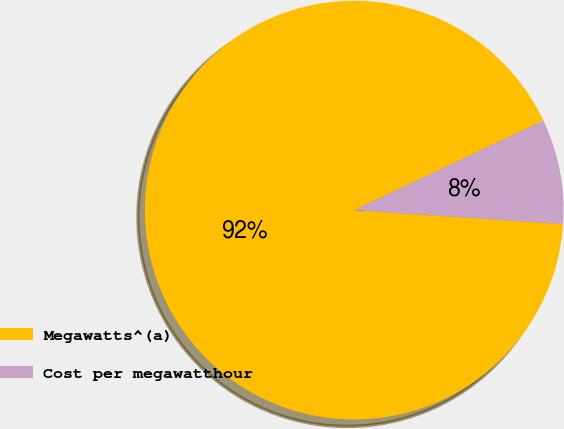Convert chart to OTSL. <chart><loc_0><loc_0><loc_500><loc_500><pie_chart><fcel>Megawatts^(a)<fcel>Cost per megawatthour<nl><fcel>91.91%<fcel>8.09%<nl></chart> 